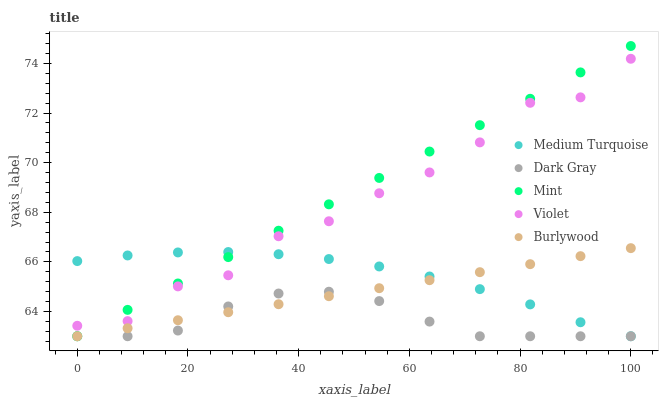Does Dark Gray have the minimum area under the curve?
Answer yes or no. Yes. Does Mint have the maximum area under the curve?
Answer yes or no. Yes. Does Burlywood have the minimum area under the curve?
Answer yes or no. No. Does Burlywood have the maximum area under the curve?
Answer yes or no. No. Is Mint the smoothest?
Answer yes or no. Yes. Is Violet the roughest?
Answer yes or no. Yes. Is Burlywood the smoothest?
Answer yes or no. No. Is Burlywood the roughest?
Answer yes or no. No. Does Dark Gray have the lowest value?
Answer yes or no. Yes. Does Violet have the lowest value?
Answer yes or no. No. Does Mint have the highest value?
Answer yes or no. Yes. Does Burlywood have the highest value?
Answer yes or no. No. Is Burlywood less than Violet?
Answer yes or no. Yes. Is Violet greater than Dark Gray?
Answer yes or no. Yes. Does Dark Gray intersect Medium Turquoise?
Answer yes or no. Yes. Is Dark Gray less than Medium Turquoise?
Answer yes or no. No. Is Dark Gray greater than Medium Turquoise?
Answer yes or no. No. Does Burlywood intersect Violet?
Answer yes or no. No. 